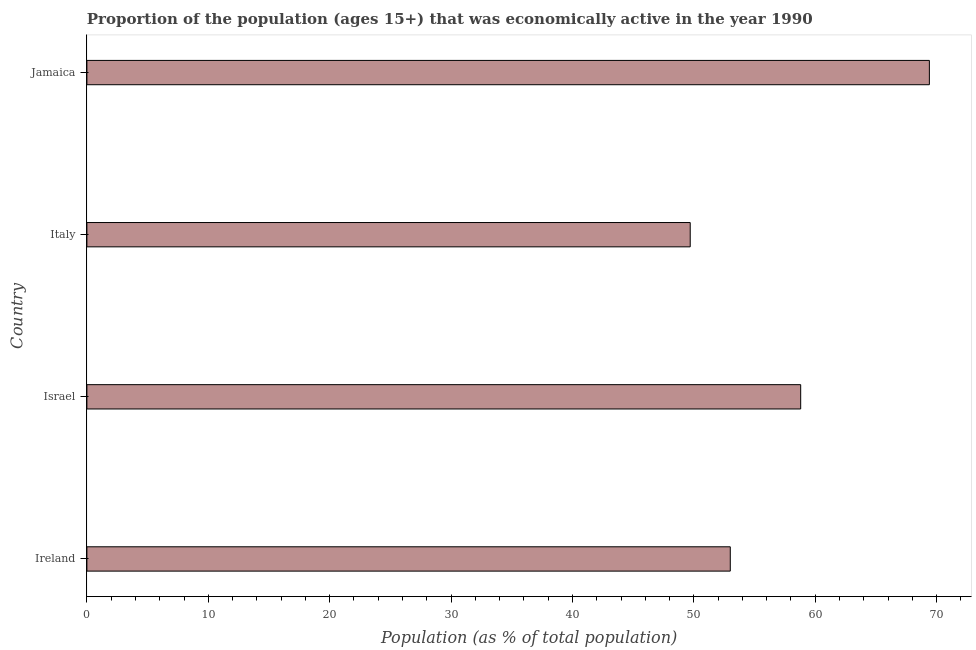Does the graph contain grids?
Keep it short and to the point. No. What is the title of the graph?
Give a very brief answer. Proportion of the population (ages 15+) that was economically active in the year 1990. What is the label or title of the X-axis?
Keep it short and to the point. Population (as % of total population). What is the percentage of economically active population in Italy?
Provide a succinct answer. 49.7. Across all countries, what is the maximum percentage of economically active population?
Keep it short and to the point. 69.4. Across all countries, what is the minimum percentage of economically active population?
Your answer should be compact. 49.7. In which country was the percentage of economically active population maximum?
Ensure brevity in your answer.  Jamaica. What is the sum of the percentage of economically active population?
Your answer should be very brief. 230.9. What is the difference between the percentage of economically active population in Israel and Jamaica?
Offer a very short reply. -10.6. What is the average percentage of economically active population per country?
Keep it short and to the point. 57.73. What is the median percentage of economically active population?
Your answer should be very brief. 55.9. In how many countries, is the percentage of economically active population greater than 30 %?
Ensure brevity in your answer.  4. What is the ratio of the percentage of economically active population in Israel to that in Italy?
Your answer should be very brief. 1.18. Is the difference between the percentage of economically active population in Ireland and Jamaica greater than the difference between any two countries?
Offer a terse response. No. Is the sum of the percentage of economically active population in Israel and Italy greater than the maximum percentage of economically active population across all countries?
Offer a very short reply. Yes. How many countries are there in the graph?
Offer a very short reply. 4. What is the difference between two consecutive major ticks on the X-axis?
Offer a terse response. 10. Are the values on the major ticks of X-axis written in scientific E-notation?
Offer a very short reply. No. What is the Population (as % of total population) in Israel?
Keep it short and to the point. 58.8. What is the Population (as % of total population) in Italy?
Give a very brief answer. 49.7. What is the Population (as % of total population) of Jamaica?
Your answer should be very brief. 69.4. What is the difference between the Population (as % of total population) in Ireland and Israel?
Provide a short and direct response. -5.8. What is the difference between the Population (as % of total population) in Ireland and Italy?
Give a very brief answer. 3.3. What is the difference between the Population (as % of total population) in Ireland and Jamaica?
Give a very brief answer. -16.4. What is the difference between the Population (as % of total population) in Israel and Jamaica?
Your answer should be compact. -10.6. What is the difference between the Population (as % of total population) in Italy and Jamaica?
Ensure brevity in your answer.  -19.7. What is the ratio of the Population (as % of total population) in Ireland to that in Israel?
Make the answer very short. 0.9. What is the ratio of the Population (as % of total population) in Ireland to that in Italy?
Provide a succinct answer. 1.07. What is the ratio of the Population (as % of total population) in Ireland to that in Jamaica?
Your answer should be very brief. 0.76. What is the ratio of the Population (as % of total population) in Israel to that in Italy?
Provide a succinct answer. 1.18. What is the ratio of the Population (as % of total population) in Israel to that in Jamaica?
Provide a succinct answer. 0.85. What is the ratio of the Population (as % of total population) in Italy to that in Jamaica?
Your response must be concise. 0.72. 